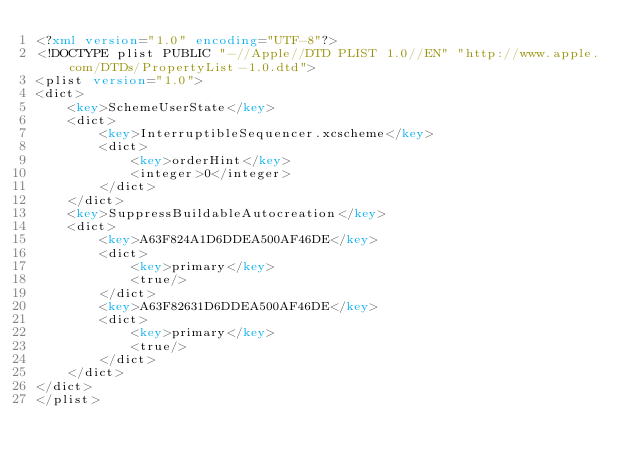<code> <loc_0><loc_0><loc_500><loc_500><_XML_><?xml version="1.0" encoding="UTF-8"?>
<!DOCTYPE plist PUBLIC "-//Apple//DTD PLIST 1.0//EN" "http://www.apple.com/DTDs/PropertyList-1.0.dtd">
<plist version="1.0">
<dict>
	<key>SchemeUserState</key>
	<dict>
		<key>InterruptibleSequencer.xcscheme</key>
		<dict>
			<key>orderHint</key>
			<integer>0</integer>
		</dict>
	</dict>
	<key>SuppressBuildableAutocreation</key>
	<dict>
		<key>A63F824A1D6DDEA500AF46DE</key>
		<dict>
			<key>primary</key>
			<true/>
		</dict>
		<key>A63F82631D6DDEA500AF46DE</key>
		<dict>
			<key>primary</key>
			<true/>
		</dict>
	</dict>
</dict>
</plist>
</code> 